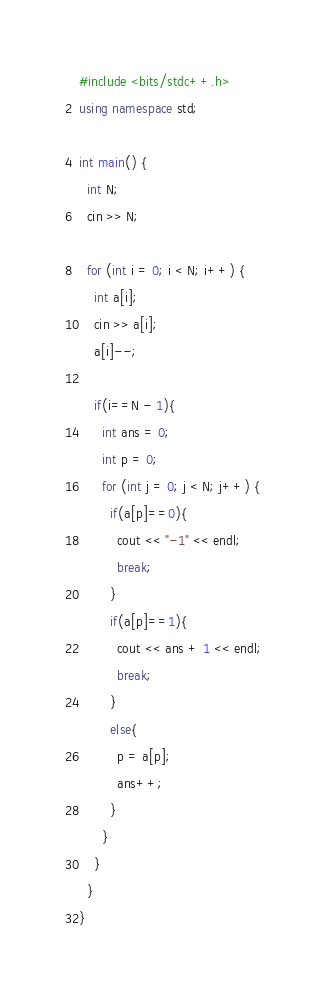<code> <loc_0><loc_0><loc_500><loc_500><_C++_>#include <bits/stdc++.h>
using namespace std;

int main() {
  int N;
  cin >> N;
  
  for (int i = 0; i < N; i++) {
    int a[i];
    cin >> a[i];
    a[i]--;
    
    if(i==N - 1){
      int ans = 0;
      int p = 0;
      for (int j = 0; j < N; j++) {
        if(a[p]==0){
          cout << "-1" << endl;
          break;
        }
        if(a[p]==1){
          cout << ans + 1 << endl;
          break;
        }
        else{
          p = a[p];
          ans++;
        }
      }
    }
  }
}
</code> 